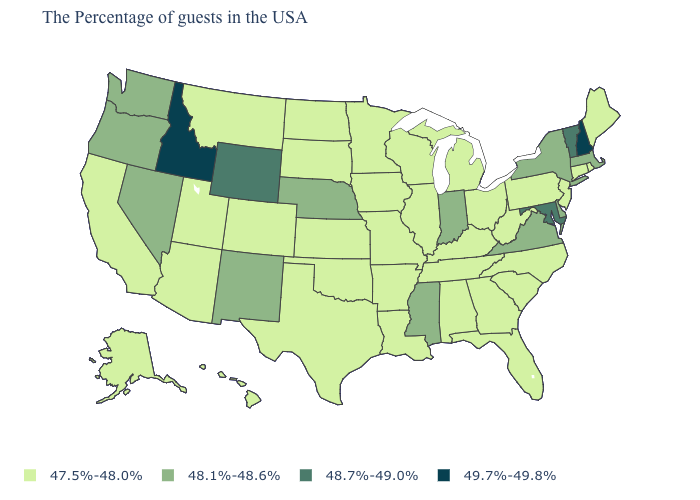Name the states that have a value in the range 47.5%-48.0%?
Quick response, please. Maine, Rhode Island, Connecticut, New Jersey, Pennsylvania, North Carolina, South Carolina, West Virginia, Ohio, Florida, Georgia, Michigan, Kentucky, Alabama, Tennessee, Wisconsin, Illinois, Louisiana, Missouri, Arkansas, Minnesota, Iowa, Kansas, Oklahoma, Texas, South Dakota, North Dakota, Colorado, Utah, Montana, Arizona, California, Alaska, Hawaii. Which states hav the highest value in the Northeast?
Short answer required. New Hampshire. Name the states that have a value in the range 48.1%-48.6%?
Write a very short answer. Massachusetts, New York, Delaware, Virginia, Indiana, Mississippi, Nebraska, New Mexico, Nevada, Washington, Oregon. How many symbols are there in the legend?
Concise answer only. 4. What is the value of New Mexico?
Be succinct. 48.1%-48.6%. What is the highest value in the West ?
Concise answer only. 49.7%-49.8%. What is the value of Mississippi?
Write a very short answer. 48.1%-48.6%. Does Illinois have the same value as Nebraska?
Quick response, please. No. Does the first symbol in the legend represent the smallest category?
Give a very brief answer. Yes. Name the states that have a value in the range 48.1%-48.6%?
Answer briefly. Massachusetts, New York, Delaware, Virginia, Indiana, Mississippi, Nebraska, New Mexico, Nevada, Washington, Oregon. Name the states that have a value in the range 49.7%-49.8%?
Quick response, please. New Hampshire, Idaho. What is the value of Hawaii?
Quick response, please. 47.5%-48.0%. Does Nebraska have a higher value than Arkansas?
Give a very brief answer. Yes. What is the highest value in the West ?
Short answer required. 49.7%-49.8%. 